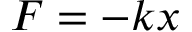Convert formula to latex. <formula><loc_0><loc_0><loc_500><loc_500>F = - k x</formula> 